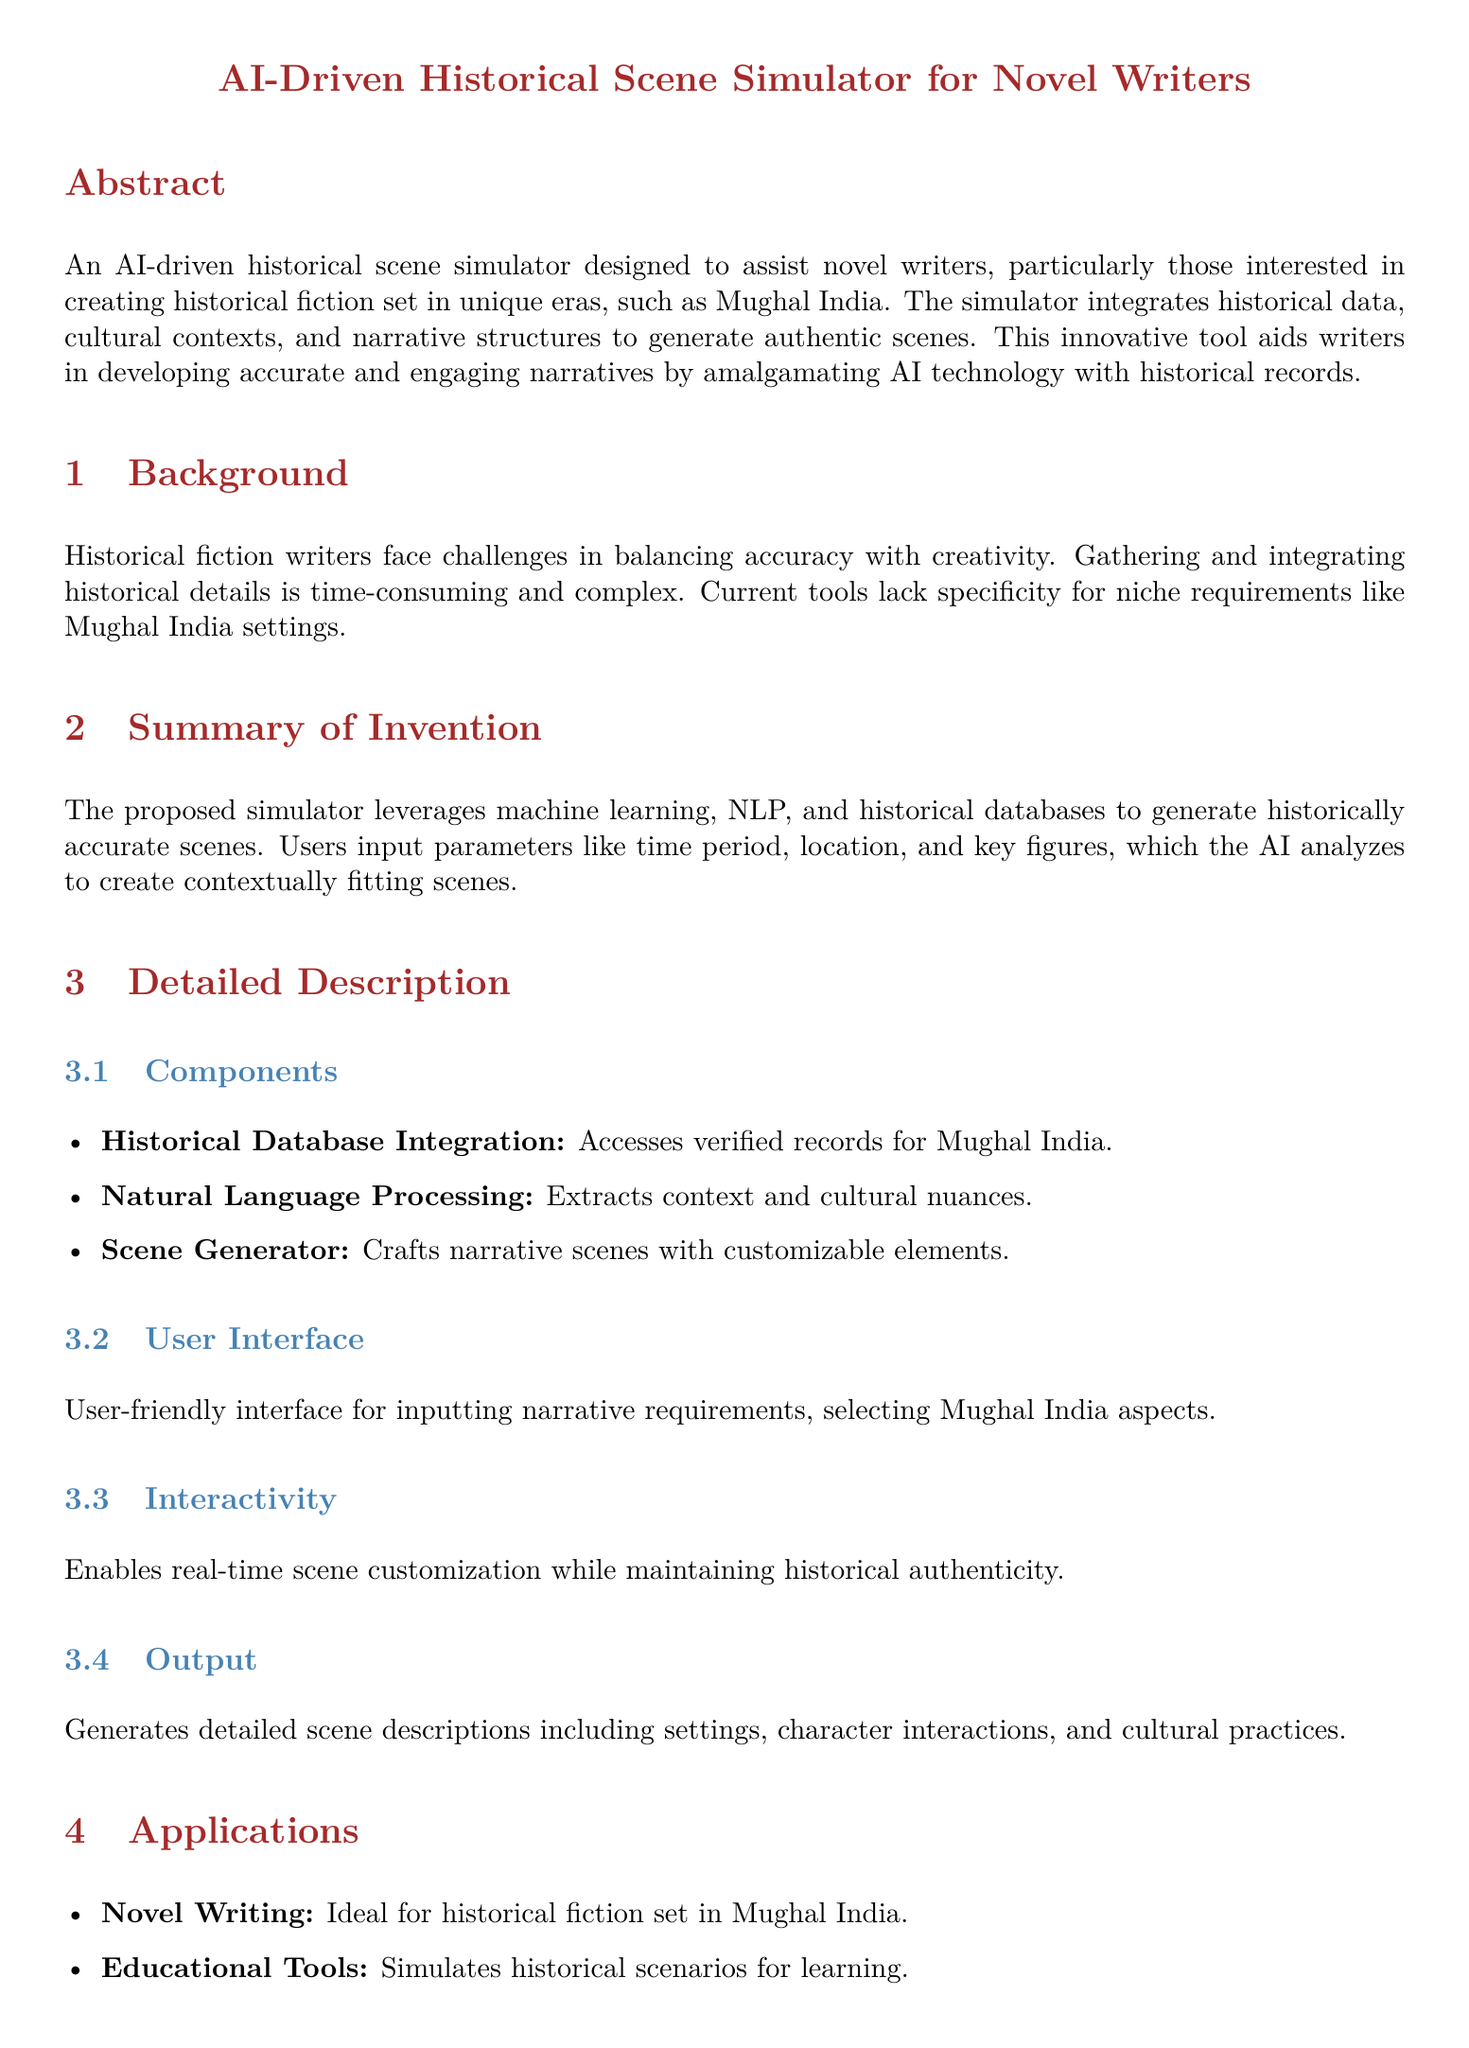what is the title of the patent application? The title of the patent application is clearly stated at the top of the document, which is "AI-Driven Historical Scene Simulator for Novel Writers."
Answer: AI-Driven Historical Scene Simulator for Novel Writers who is the inventor of the simulator? The inventor is mentioned at the end of the document, in the section specifying the patent application details.
Answer: A Novelist specializing in Mughal India Historical Fiction what is the primary purpose of the AI-driven historical scene simulator? The primary purpose is outlined in the abstract, which mentions assisting novel writers in creating historical fiction.
Answer: Assist novel writers what are the main components of the simulator? The detailed description section lists the main components, which includes Historical Database Integration, Natural Language Processing, and Scene Generator.
Answer: Historical Database Integration, Natural Language Processing, Scene Generator what advantages does the AI-driven historical scene simulator offer? The advantages listed include time efficiency, accuracy, and customization, which are all specifically noted in the advantages section.
Answer: Time Efficiency, Accuracy, Customization how does the user interface function? The user interface is described in the detailed description section, specifying it allows for inputting narrative requirements.
Answer: User-friendly interface for inputting narrative requirements what historical context is the simulator focused on? The focus of the simulator is mentioned in the abstract and throughout the document, emphasizing Mughal India.
Answer: Mughal India what technology is primarily used in the simulator? The technology involved is highlighted in the summary of invention, which mentions machine learning and NLP.
Answer: Machine learning, NLP 